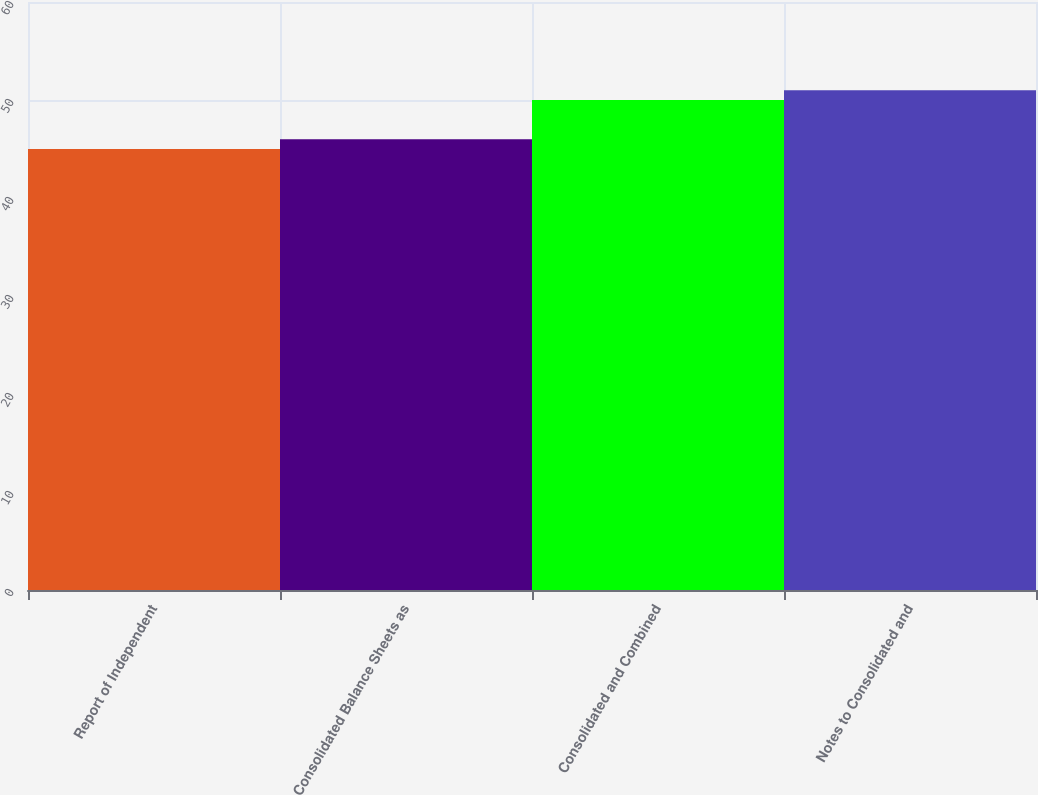<chart> <loc_0><loc_0><loc_500><loc_500><bar_chart><fcel>Report of Independent<fcel>Consolidated Balance Sheets as<fcel>Consolidated and Combined<fcel>Notes to Consolidated and<nl><fcel>45<fcel>46<fcel>50<fcel>51<nl></chart> 